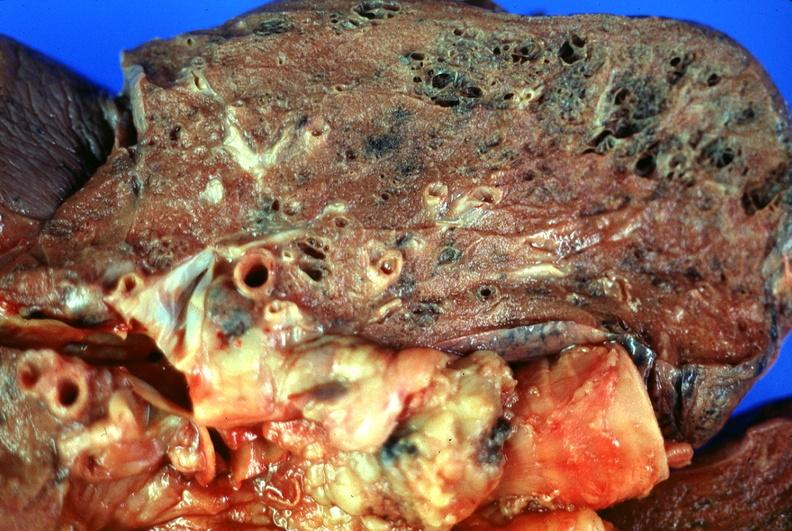where is this?
Answer the question using a single word or phrase. Lung 